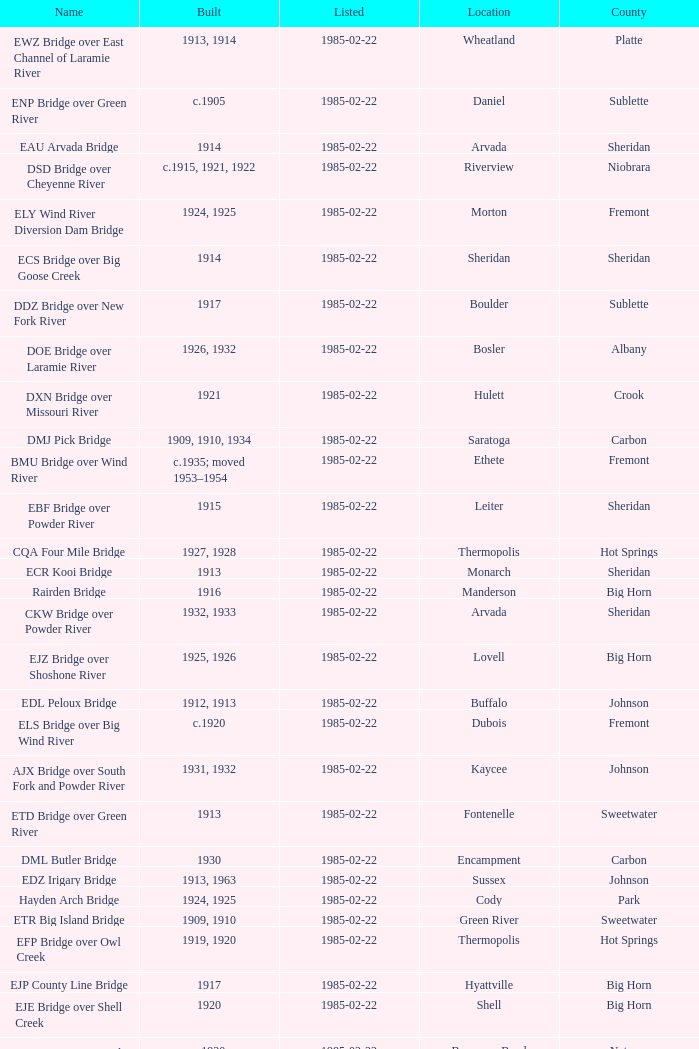What is the listed for the bridge at Daniel in Sublette county? 1985-02-22. 